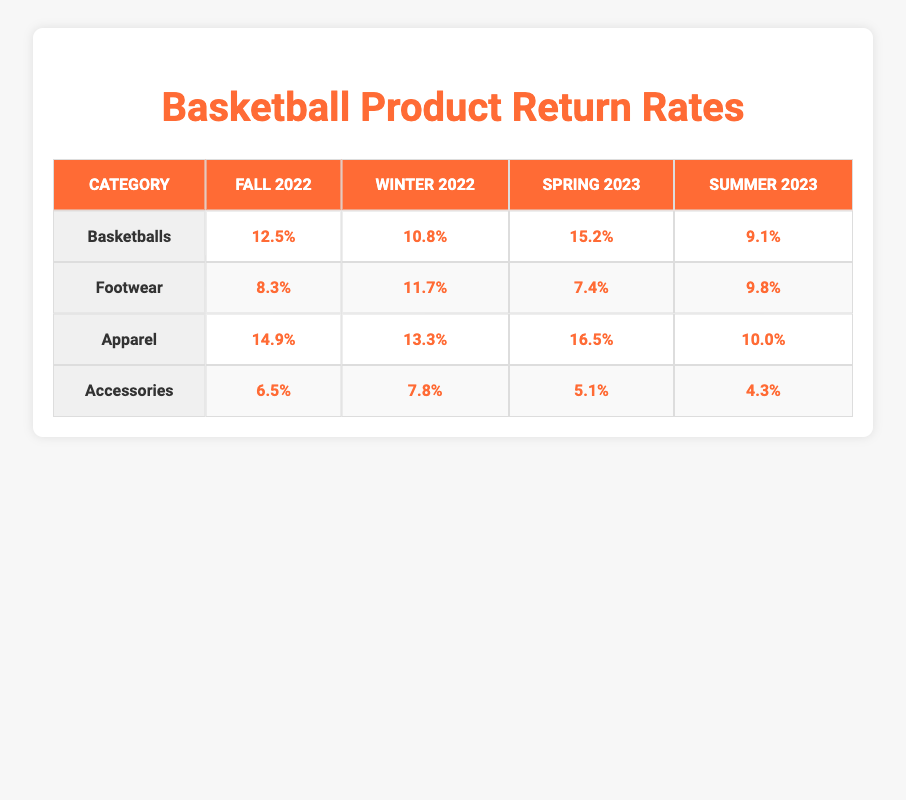What is the return rate for basketballs in Winter 2022? The table lists the return rate for each category in each season. For basketballs in Winter 2022, the return rate is clearly indicated as 10.8%.
Answer: 10.8% What is the return rate for accessories in Summer 2023? By inspecting the table, we can find that the return rate for accessories in Summer 2023 is recorded as 4.3%.
Answer: 4.3% Which category had the highest return rate in Spring 2023? Looking across the Spring 2023 column, the apparel category shows the highest return rate at 16.5%, compared to basketballs (15.2%), footwear (7.4%), and accessories (5.1%).
Answer: Apparel What is the average return rate for footwear across all seasons? To find the average, we need to sum the return rates for footwear: (8.3 + 11.7 + 7.4 + 9.8) = 37.2. Then, we divide by the number of seasons (4): 37.2 / 4 = 9.3.
Answer: 9.3 Did the return rate for basketballs decrease from Winter 2022 to Summer 2023? In Winter 2022, the return rate was 10.8%, and in Summer 2023, it was 9.1%. Since 9.1% is less than 10.8%, the return rate did indeed decrease.
Answer: Yes What category has the lowest return rate overall? By examining all the return rates, the accessories category has the lowest return rate at 4.3% during the Summer 2023 season.
Answer: Accessories What is the total return rate for apparel during Fall 2022 and Winter 2022? The total return rate for apparel in these two seasons is (14.9% + 13.3%) = 28.2%.
Answer: 28.2% Which season had the highest return rate across all product categories? By comparing the return rates for each season across all categories: Fall 2022 has 12.5% (B), 8.3% (F), 14.9% (A), 6.5% (A) = 41.2%, Winter 2022 has 10.8% (B), 11.7% (F), 13.3% (A), 7.8% (A) = 43.6%, Spring 2023 has 15.2% (B), 7.4% (F), 16.5% (A), 5.1% (A) = 44.2%, and Summer 2023 has 9.1% (B), 9.8% (F), 10.0% (A), 4.3% (A) = 33.2%. Therefore, Spring 2023 had the highest aggregate return rate at 44.2%.
Answer: Spring 2023 Is the return rate for accessories lower in Spring 2023 than in Fall 2022? In the table, the return rate for accessories in Spring 2023 is 5.1% and in Fall 2022 is 6.5%. Since 5.1% is less than 6.5%, the return rate is lower.
Answer: Yes What is the difference in return rates between basketballs and footwear in Winter 2022? The return rate for basketballs in Winter 2022 is 10.8%, while footwear is 11.7%. The difference is calculated as 11.7% - 10.8% = 0.9%.
Answer: 0.9% 